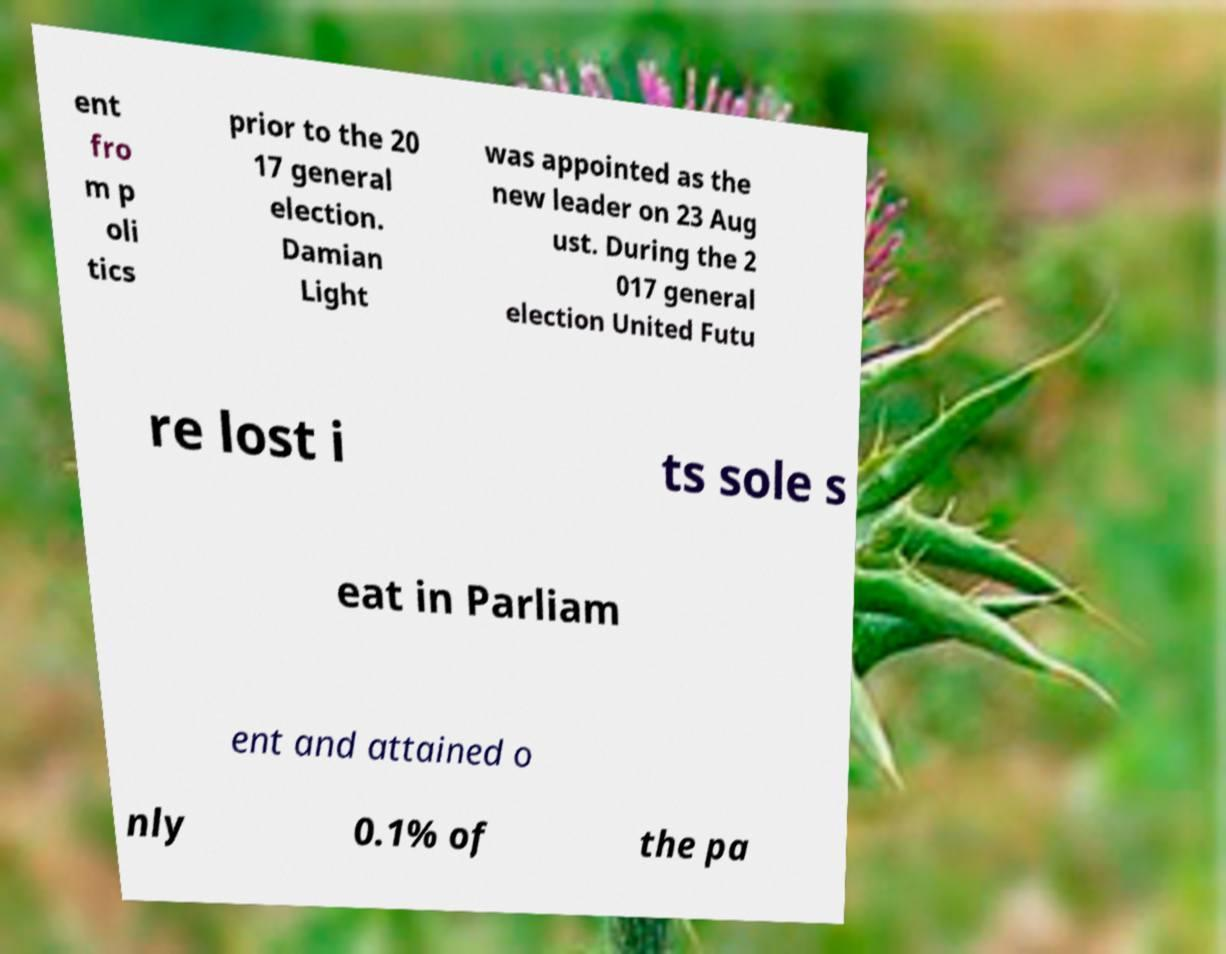Please read and relay the text visible in this image. What does it say? ent fro m p oli tics prior to the 20 17 general election. Damian Light was appointed as the new leader on 23 Aug ust. During the 2 017 general election United Futu re lost i ts sole s eat in Parliam ent and attained o nly 0.1% of the pa 